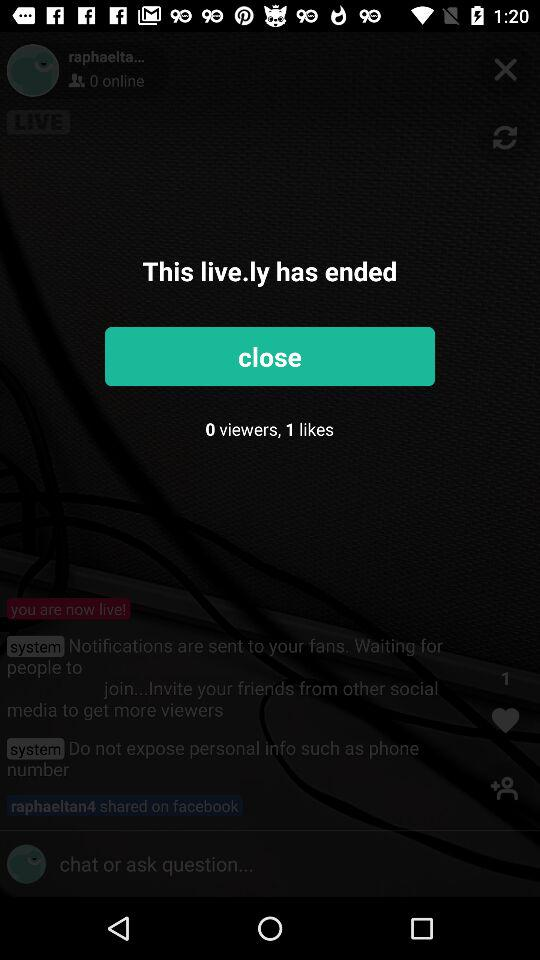How many likes are shown? There is only 1 like. 